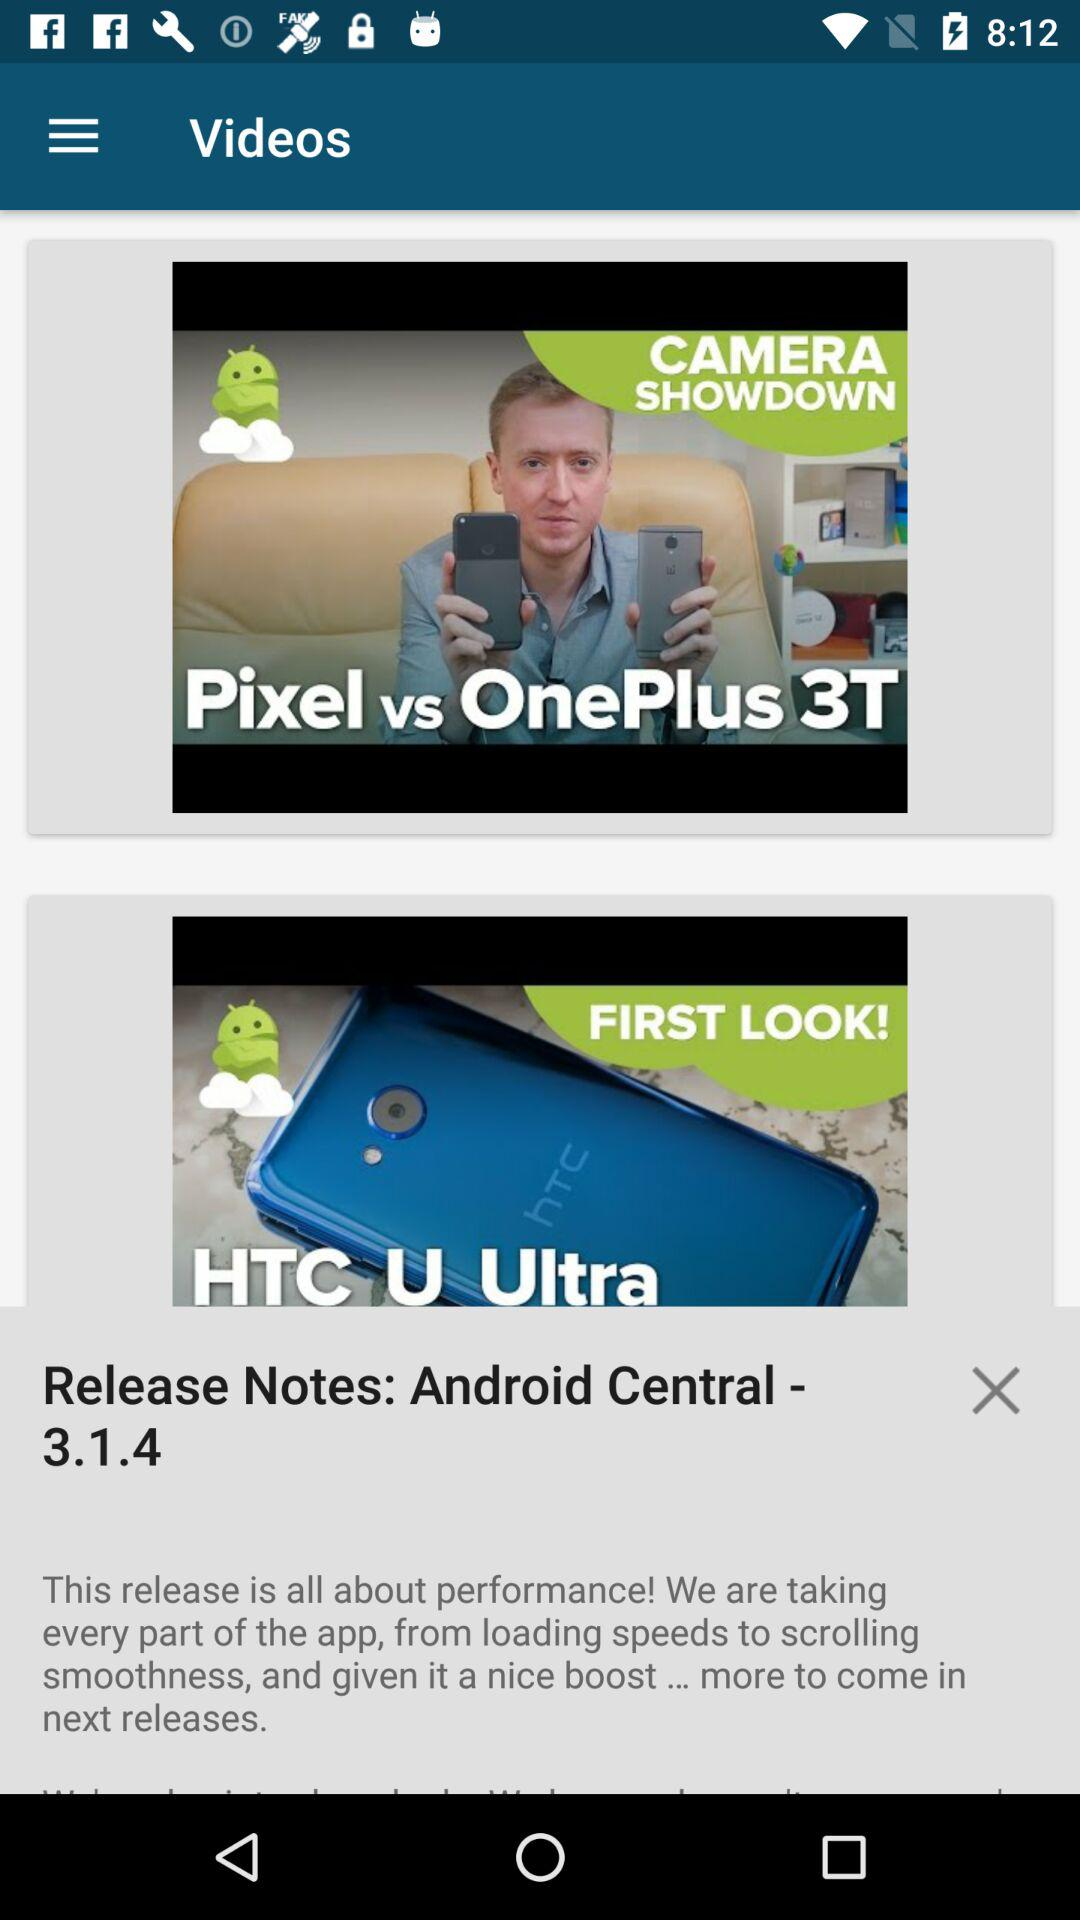What is the version? The version is 3.1.4. 